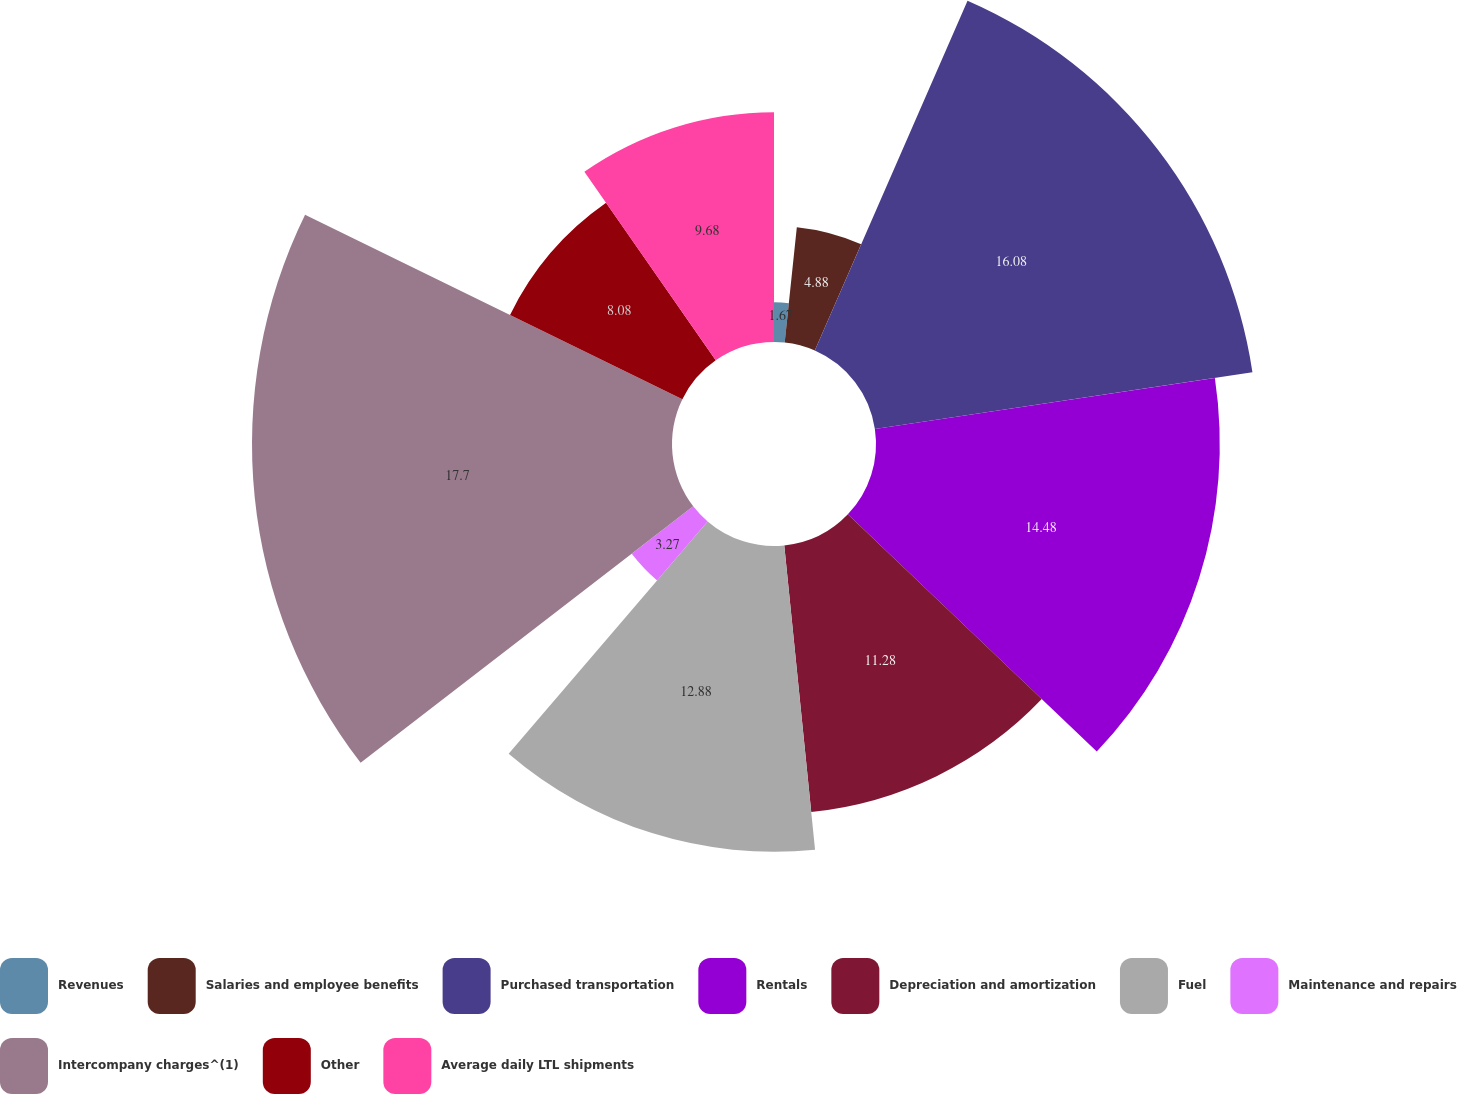Convert chart to OTSL. <chart><loc_0><loc_0><loc_500><loc_500><pie_chart><fcel>Revenues<fcel>Salaries and employee benefits<fcel>Purchased transportation<fcel>Rentals<fcel>Depreciation and amortization<fcel>Fuel<fcel>Maintenance and repairs<fcel>Intercompany charges^(1)<fcel>Other<fcel>Average daily LTL shipments<nl><fcel>1.67%<fcel>4.88%<fcel>16.08%<fcel>14.48%<fcel>11.28%<fcel>12.88%<fcel>3.27%<fcel>17.69%<fcel>8.08%<fcel>9.68%<nl></chart> 